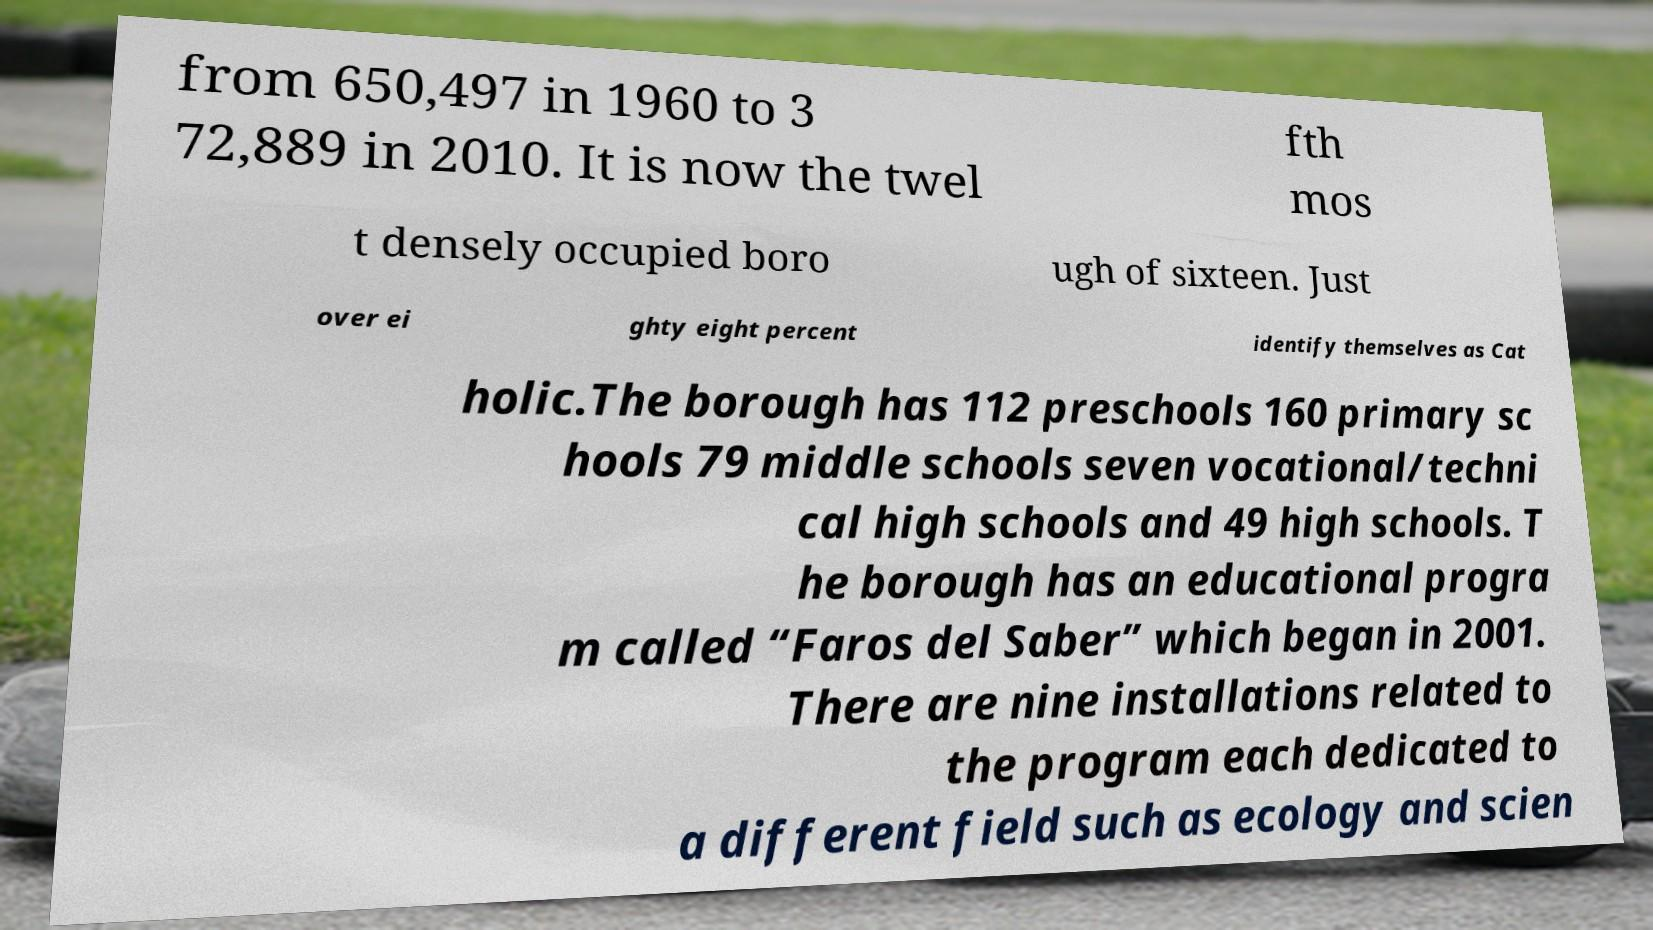Can you read and provide the text displayed in the image?This photo seems to have some interesting text. Can you extract and type it out for me? from 650,497 in 1960 to 3 72,889 in 2010. It is now the twel fth mos t densely occupied boro ugh of sixteen. Just over ei ghty eight percent identify themselves as Cat holic.The borough has 112 preschools 160 primary sc hools 79 middle schools seven vocational/techni cal high schools and 49 high schools. T he borough has an educational progra m called “Faros del Saber” which began in 2001. There are nine installations related to the program each dedicated to a different field such as ecology and scien 